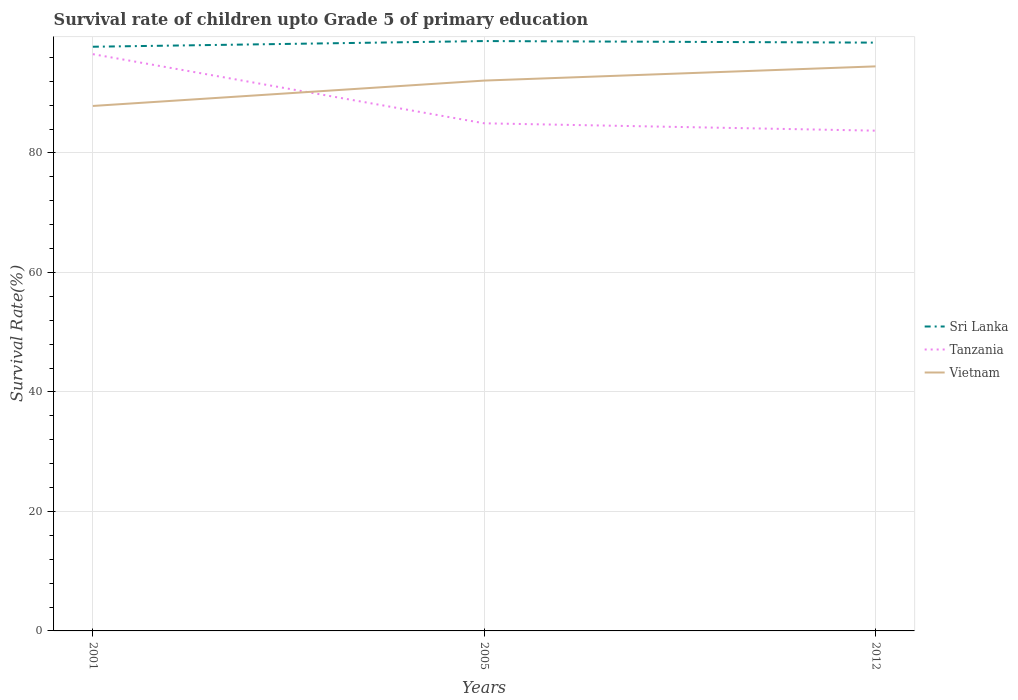Does the line corresponding to Tanzania intersect with the line corresponding to Vietnam?
Your answer should be compact. Yes. Across all years, what is the maximum survival rate of children in Sri Lanka?
Ensure brevity in your answer.  97.79. What is the total survival rate of children in Vietnam in the graph?
Keep it short and to the point. -4.25. What is the difference between the highest and the second highest survival rate of children in Sri Lanka?
Your response must be concise. 0.95. How many lines are there?
Give a very brief answer. 3. How many years are there in the graph?
Your answer should be very brief. 3. How are the legend labels stacked?
Your answer should be compact. Vertical. What is the title of the graph?
Offer a terse response. Survival rate of children upto Grade 5 of primary education. Does "High income" appear as one of the legend labels in the graph?
Your answer should be compact. No. What is the label or title of the Y-axis?
Your answer should be very brief. Survival Rate(%). What is the Survival Rate(%) of Sri Lanka in 2001?
Offer a very short reply. 97.79. What is the Survival Rate(%) in Tanzania in 2001?
Your answer should be very brief. 96.54. What is the Survival Rate(%) in Vietnam in 2001?
Offer a very short reply. 87.87. What is the Survival Rate(%) of Sri Lanka in 2005?
Make the answer very short. 98.74. What is the Survival Rate(%) of Tanzania in 2005?
Make the answer very short. 84.97. What is the Survival Rate(%) in Vietnam in 2005?
Make the answer very short. 92.12. What is the Survival Rate(%) of Sri Lanka in 2012?
Offer a terse response. 98.47. What is the Survival Rate(%) of Tanzania in 2012?
Offer a terse response. 83.74. What is the Survival Rate(%) of Vietnam in 2012?
Your answer should be very brief. 94.5. Across all years, what is the maximum Survival Rate(%) in Sri Lanka?
Give a very brief answer. 98.74. Across all years, what is the maximum Survival Rate(%) in Tanzania?
Make the answer very short. 96.54. Across all years, what is the maximum Survival Rate(%) in Vietnam?
Provide a short and direct response. 94.5. Across all years, what is the minimum Survival Rate(%) in Sri Lanka?
Offer a very short reply. 97.79. Across all years, what is the minimum Survival Rate(%) in Tanzania?
Offer a terse response. 83.74. Across all years, what is the minimum Survival Rate(%) of Vietnam?
Offer a terse response. 87.87. What is the total Survival Rate(%) of Sri Lanka in the graph?
Offer a terse response. 294.99. What is the total Survival Rate(%) in Tanzania in the graph?
Provide a short and direct response. 265.25. What is the total Survival Rate(%) in Vietnam in the graph?
Keep it short and to the point. 274.49. What is the difference between the Survival Rate(%) in Sri Lanka in 2001 and that in 2005?
Offer a terse response. -0.95. What is the difference between the Survival Rate(%) in Tanzania in 2001 and that in 2005?
Keep it short and to the point. 11.57. What is the difference between the Survival Rate(%) of Vietnam in 2001 and that in 2005?
Offer a very short reply. -4.25. What is the difference between the Survival Rate(%) in Sri Lanka in 2001 and that in 2012?
Make the answer very short. -0.69. What is the difference between the Survival Rate(%) of Tanzania in 2001 and that in 2012?
Make the answer very short. 12.8. What is the difference between the Survival Rate(%) of Vietnam in 2001 and that in 2012?
Make the answer very short. -6.62. What is the difference between the Survival Rate(%) in Sri Lanka in 2005 and that in 2012?
Make the answer very short. 0.26. What is the difference between the Survival Rate(%) of Tanzania in 2005 and that in 2012?
Offer a very short reply. 1.23. What is the difference between the Survival Rate(%) of Vietnam in 2005 and that in 2012?
Give a very brief answer. -2.38. What is the difference between the Survival Rate(%) in Sri Lanka in 2001 and the Survival Rate(%) in Tanzania in 2005?
Your answer should be very brief. 12.82. What is the difference between the Survival Rate(%) of Sri Lanka in 2001 and the Survival Rate(%) of Vietnam in 2005?
Ensure brevity in your answer.  5.66. What is the difference between the Survival Rate(%) of Tanzania in 2001 and the Survival Rate(%) of Vietnam in 2005?
Provide a succinct answer. 4.42. What is the difference between the Survival Rate(%) of Sri Lanka in 2001 and the Survival Rate(%) of Tanzania in 2012?
Your response must be concise. 14.05. What is the difference between the Survival Rate(%) of Sri Lanka in 2001 and the Survival Rate(%) of Vietnam in 2012?
Ensure brevity in your answer.  3.29. What is the difference between the Survival Rate(%) in Tanzania in 2001 and the Survival Rate(%) in Vietnam in 2012?
Your answer should be compact. 2.04. What is the difference between the Survival Rate(%) in Sri Lanka in 2005 and the Survival Rate(%) in Tanzania in 2012?
Ensure brevity in your answer.  15. What is the difference between the Survival Rate(%) in Sri Lanka in 2005 and the Survival Rate(%) in Vietnam in 2012?
Provide a succinct answer. 4.24. What is the difference between the Survival Rate(%) of Tanzania in 2005 and the Survival Rate(%) of Vietnam in 2012?
Make the answer very short. -9.53. What is the average Survival Rate(%) of Sri Lanka per year?
Your answer should be compact. 98.33. What is the average Survival Rate(%) of Tanzania per year?
Ensure brevity in your answer.  88.42. What is the average Survival Rate(%) of Vietnam per year?
Ensure brevity in your answer.  91.5. In the year 2001, what is the difference between the Survival Rate(%) in Sri Lanka and Survival Rate(%) in Tanzania?
Offer a terse response. 1.24. In the year 2001, what is the difference between the Survival Rate(%) in Sri Lanka and Survival Rate(%) in Vietnam?
Offer a terse response. 9.91. In the year 2001, what is the difference between the Survival Rate(%) of Tanzania and Survival Rate(%) of Vietnam?
Your response must be concise. 8.67. In the year 2005, what is the difference between the Survival Rate(%) in Sri Lanka and Survival Rate(%) in Tanzania?
Provide a succinct answer. 13.77. In the year 2005, what is the difference between the Survival Rate(%) in Sri Lanka and Survival Rate(%) in Vietnam?
Provide a short and direct response. 6.62. In the year 2005, what is the difference between the Survival Rate(%) in Tanzania and Survival Rate(%) in Vietnam?
Give a very brief answer. -7.15. In the year 2012, what is the difference between the Survival Rate(%) of Sri Lanka and Survival Rate(%) of Tanzania?
Your response must be concise. 14.74. In the year 2012, what is the difference between the Survival Rate(%) in Sri Lanka and Survival Rate(%) in Vietnam?
Keep it short and to the point. 3.97. In the year 2012, what is the difference between the Survival Rate(%) in Tanzania and Survival Rate(%) in Vietnam?
Provide a succinct answer. -10.76. What is the ratio of the Survival Rate(%) in Sri Lanka in 2001 to that in 2005?
Ensure brevity in your answer.  0.99. What is the ratio of the Survival Rate(%) in Tanzania in 2001 to that in 2005?
Provide a succinct answer. 1.14. What is the ratio of the Survival Rate(%) of Vietnam in 2001 to that in 2005?
Keep it short and to the point. 0.95. What is the ratio of the Survival Rate(%) of Sri Lanka in 2001 to that in 2012?
Provide a short and direct response. 0.99. What is the ratio of the Survival Rate(%) in Tanzania in 2001 to that in 2012?
Ensure brevity in your answer.  1.15. What is the ratio of the Survival Rate(%) in Vietnam in 2001 to that in 2012?
Your answer should be compact. 0.93. What is the ratio of the Survival Rate(%) in Sri Lanka in 2005 to that in 2012?
Provide a short and direct response. 1. What is the ratio of the Survival Rate(%) of Tanzania in 2005 to that in 2012?
Give a very brief answer. 1.01. What is the ratio of the Survival Rate(%) in Vietnam in 2005 to that in 2012?
Make the answer very short. 0.97. What is the difference between the highest and the second highest Survival Rate(%) of Sri Lanka?
Provide a short and direct response. 0.26. What is the difference between the highest and the second highest Survival Rate(%) of Tanzania?
Keep it short and to the point. 11.57. What is the difference between the highest and the second highest Survival Rate(%) in Vietnam?
Offer a very short reply. 2.38. What is the difference between the highest and the lowest Survival Rate(%) of Sri Lanka?
Ensure brevity in your answer.  0.95. What is the difference between the highest and the lowest Survival Rate(%) in Tanzania?
Ensure brevity in your answer.  12.8. What is the difference between the highest and the lowest Survival Rate(%) in Vietnam?
Keep it short and to the point. 6.62. 